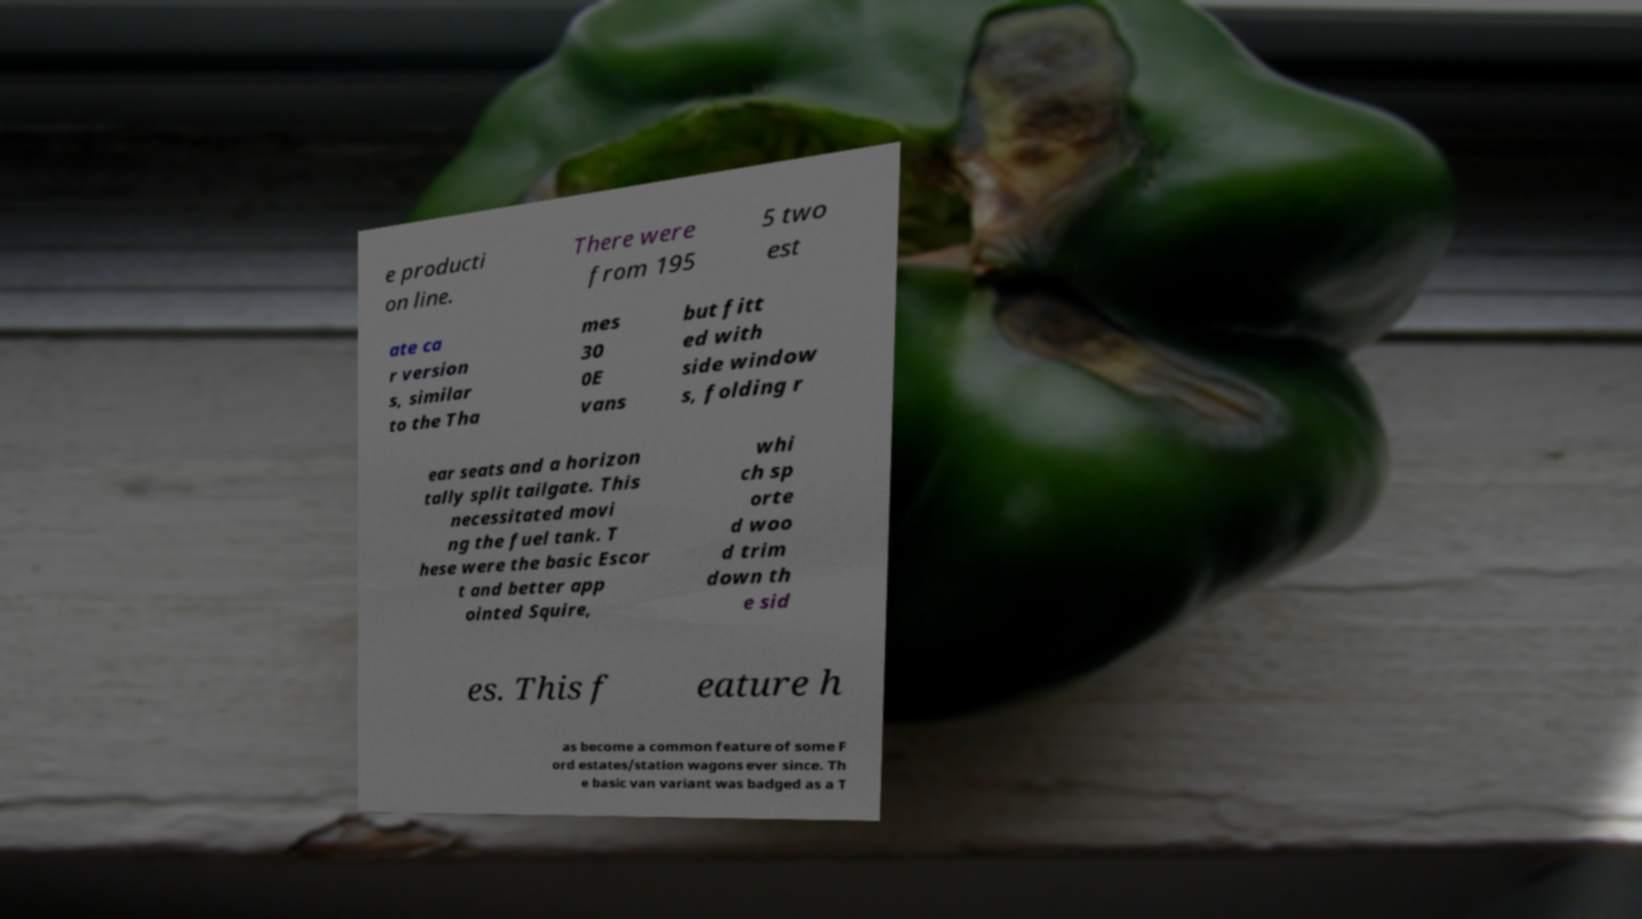What messages or text are displayed in this image? I need them in a readable, typed format. e producti on line. There were from 195 5 two est ate ca r version s, similar to the Tha mes 30 0E vans but fitt ed with side window s, folding r ear seats and a horizon tally split tailgate. This necessitated movi ng the fuel tank. T hese were the basic Escor t and better app ointed Squire, whi ch sp orte d woo d trim down th e sid es. This f eature h as become a common feature of some F ord estates/station wagons ever since. Th e basic van variant was badged as a T 